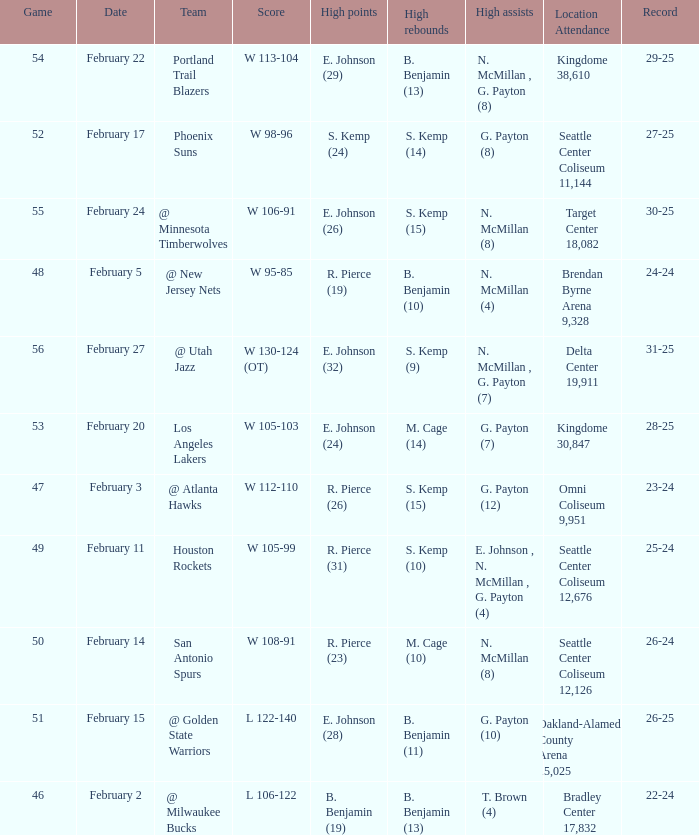Which game had a score of w 95-85? 48.0. 